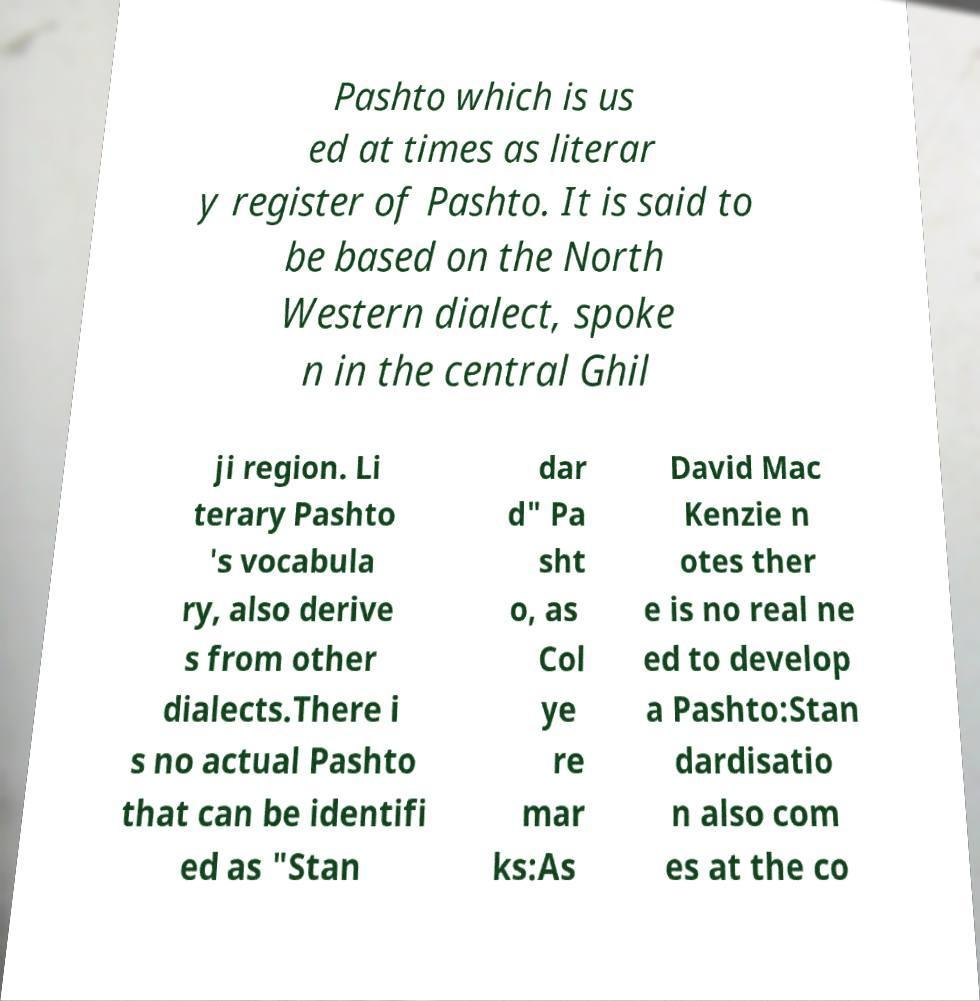Can you accurately transcribe the text from the provided image for me? Pashto which is us ed at times as literar y register of Pashto. It is said to be based on the North Western dialect, spoke n in the central Ghil ji region. Li terary Pashto 's vocabula ry, also derive s from other dialects.There i s no actual Pashto that can be identifi ed as "Stan dar d" Pa sht o, as Col ye re mar ks:As David Mac Kenzie n otes ther e is no real ne ed to develop a Pashto:Stan dardisatio n also com es at the co 